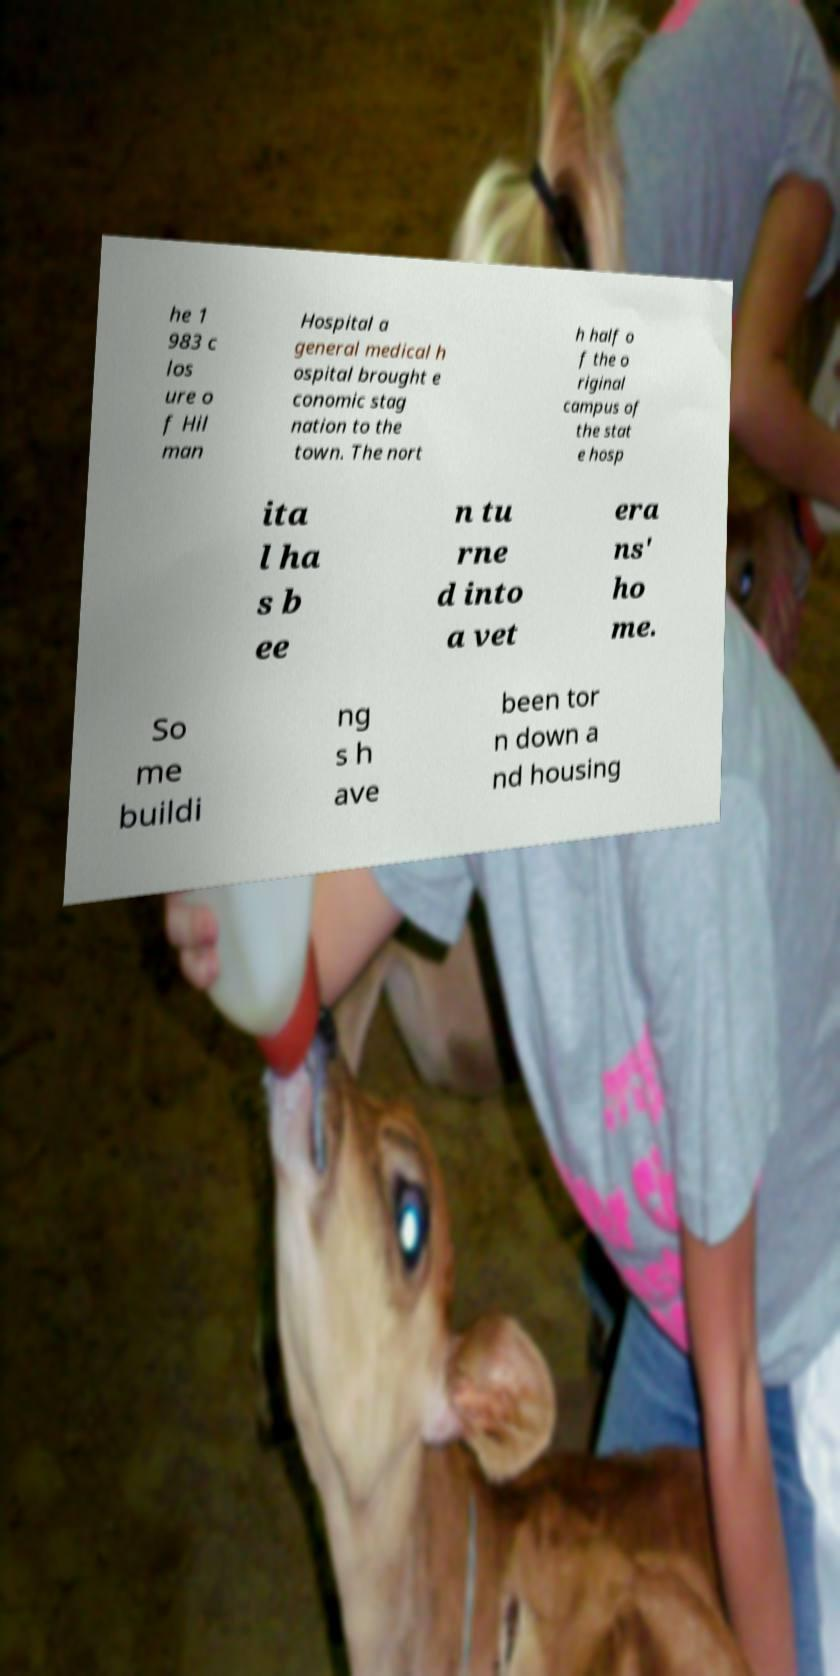Could you assist in decoding the text presented in this image and type it out clearly? he 1 983 c los ure o f Hil man Hospital a general medical h ospital brought e conomic stag nation to the town. The nort h half o f the o riginal campus of the stat e hosp ita l ha s b ee n tu rne d into a vet era ns' ho me. So me buildi ng s h ave been tor n down a nd housing 